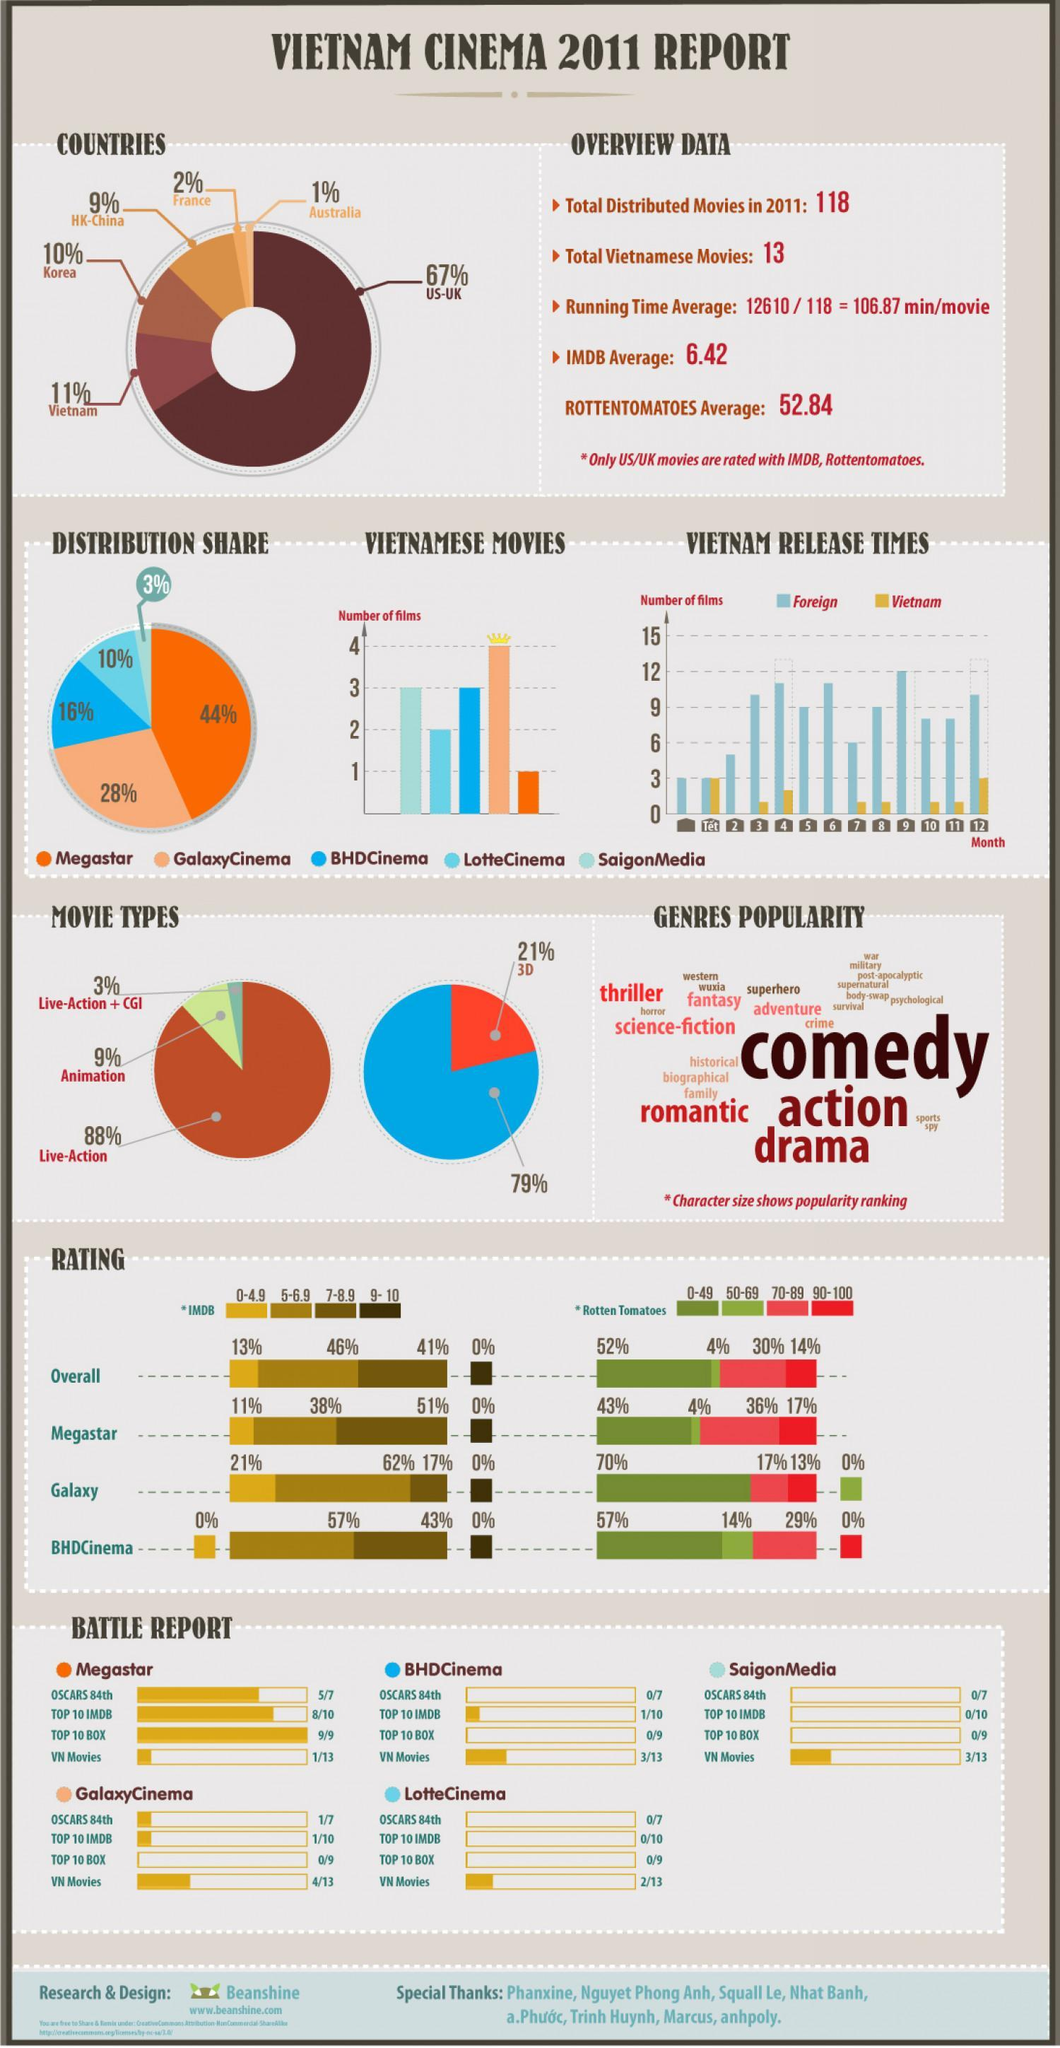Which distributor has the lowest distribution share?
Answer the question with a short phrase. SaigonMedia Which two distributors have less than three films? BHD cinema, Megastar Who has distributed more movies - Vietnam, France or Korea? Vietnam Out of the total distributed movies, how many are 'not' Vietnamese? 105 Which distributor has the highest percentage of IMDB rating between 7 - 8.9? Megastar What percent of the movies are from Vietnam? 11% What is the total distribution share of BHD cinema and Lotte cinema? 26% What percent of the movies are from US-UK? 67% Which movies distributor has the highest number of films? GalaxyCinema Which distributor has the highest distribution share? Megastar What percent of the movies are not 3D? 79% What percent of the movies are of animation type? 9% How many bullet points are there under "overview data"? 4 What is the percentage of movies distributed by HK - China? 9% What percent of the movies are 3D? 21% Which is the second most popular genre? Action Which country has distributed the least number of movies? Australia Which is the most popular genre? Comedy 